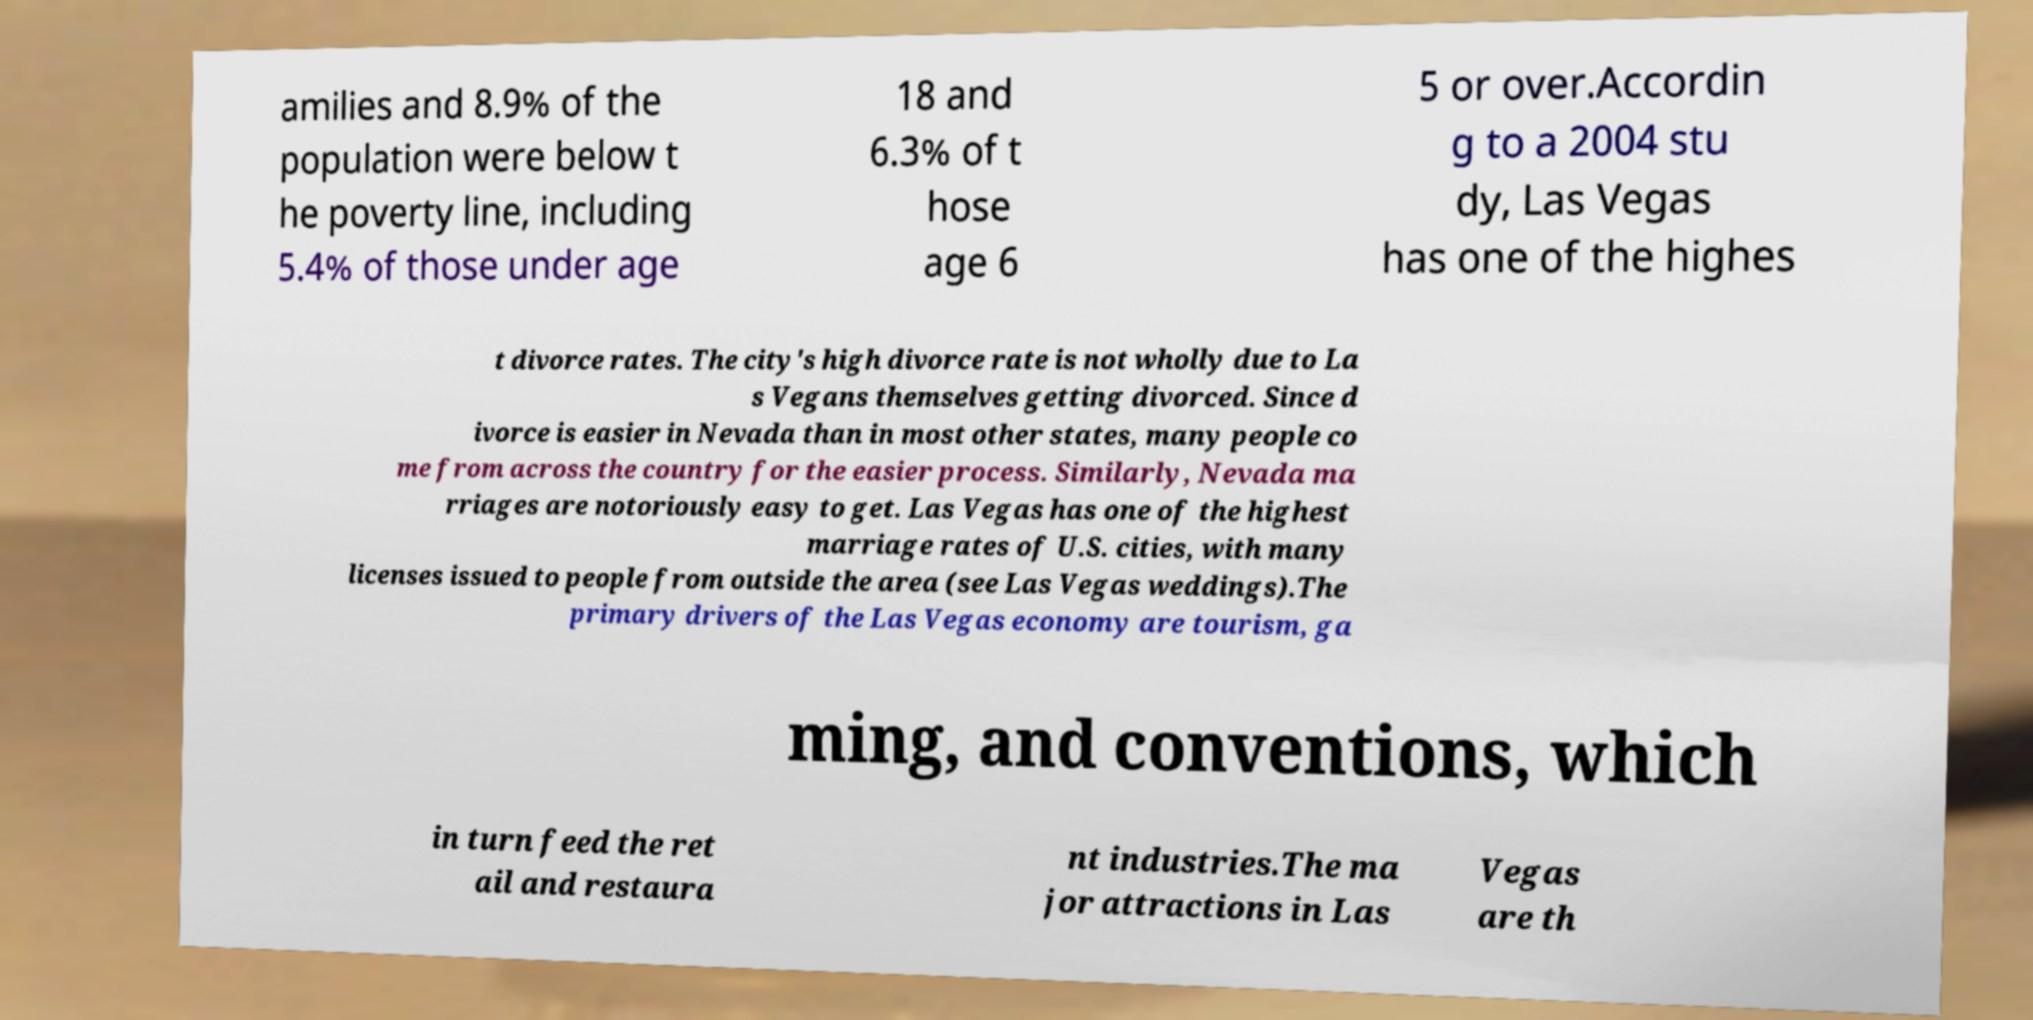I need the written content from this picture converted into text. Can you do that? amilies and 8.9% of the population were below t he poverty line, including 5.4% of those under age 18 and 6.3% of t hose age 6 5 or over.Accordin g to a 2004 stu dy, Las Vegas has one of the highes t divorce rates. The city's high divorce rate is not wholly due to La s Vegans themselves getting divorced. Since d ivorce is easier in Nevada than in most other states, many people co me from across the country for the easier process. Similarly, Nevada ma rriages are notoriously easy to get. Las Vegas has one of the highest marriage rates of U.S. cities, with many licenses issued to people from outside the area (see Las Vegas weddings).The primary drivers of the Las Vegas economy are tourism, ga ming, and conventions, which in turn feed the ret ail and restaura nt industries.The ma jor attractions in Las Vegas are th 